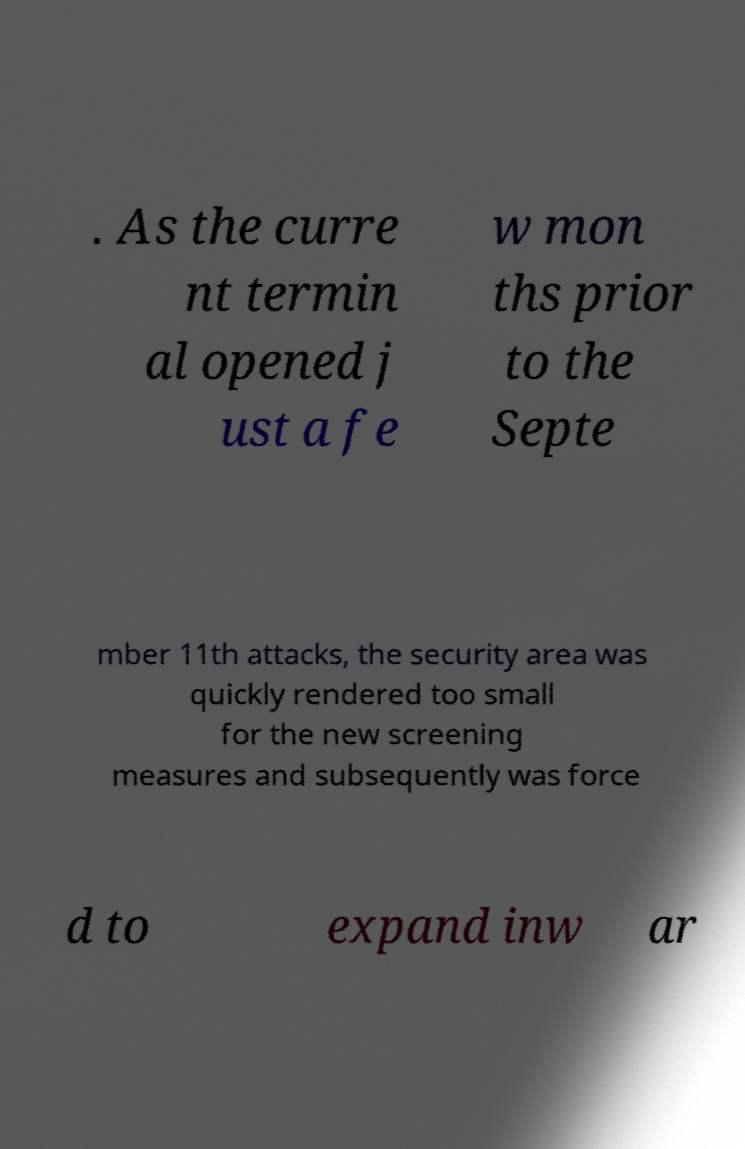Please read and relay the text visible in this image. What does it say? . As the curre nt termin al opened j ust a fe w mon ths prior to the Septe mber 11th attacks, the security area was quickly rendered too small for the new screening measures and subsequently was force d to expand inw ar 